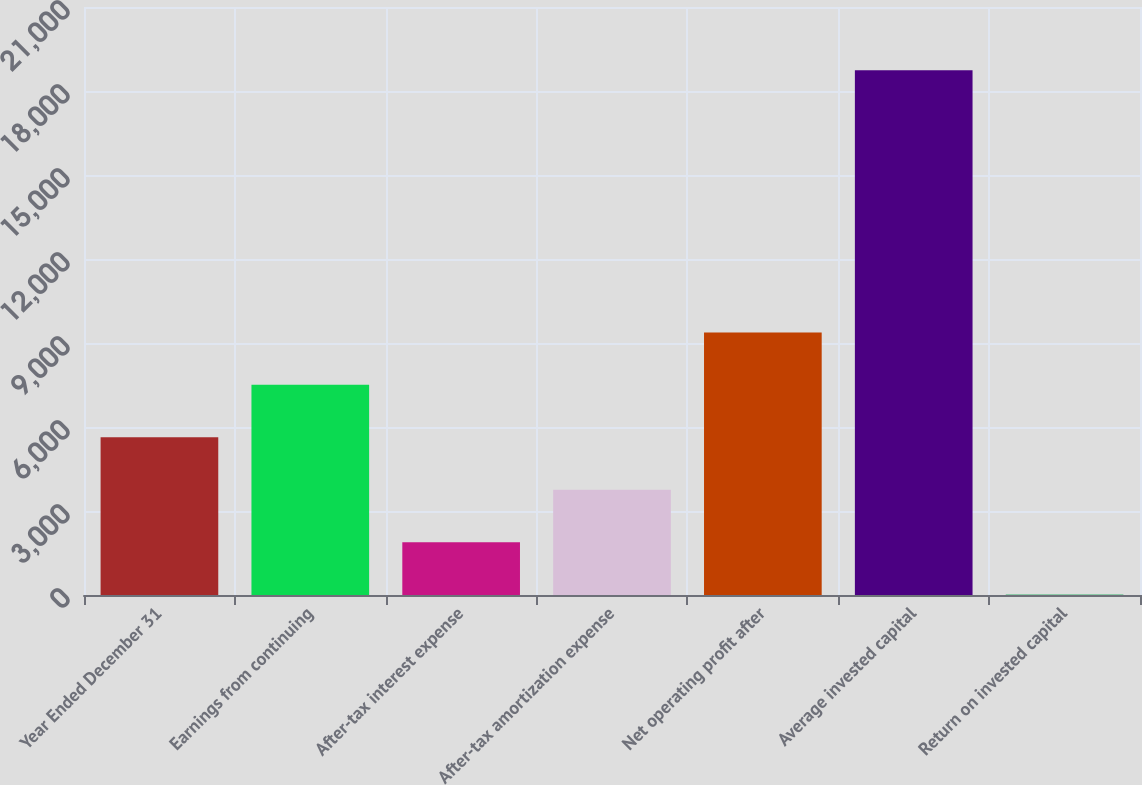<chart> <loc_0><loc_0><loc_500><loc_500><bar_chart><fcel>Year Ended December 31<fcel>Earnings from continuing<fcel>After-tax interest expense<fcel>After-tax amortization expense<fcel>Net operating profit after<fcel>Average invested capital<fcel>Return on invested capital<nl><fcel>5632.17<fcel>7504.86<fcel>1886.79<fcel>3759.48<fcel>9377.55<fcel>18741<fcel>14.1<nl></chart> 